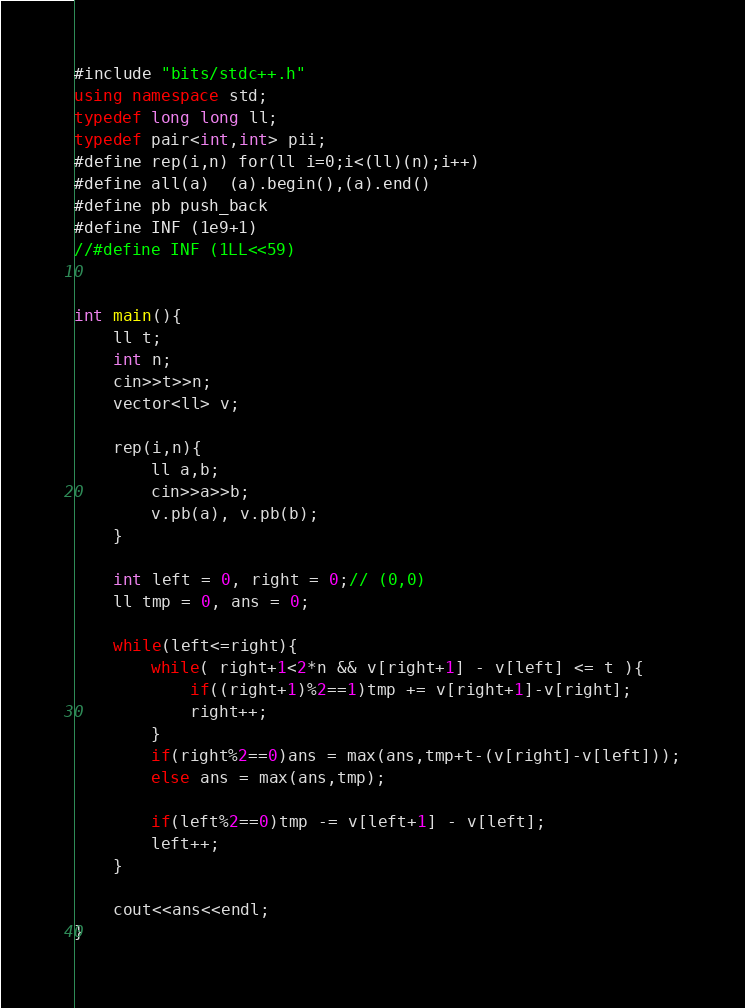Convert code to text. <code><loc_0><loc_0><loc_500><loc_500><_C++_>#include "bits/stdc++.h"
using namespace std;
typedef long long ll;
typedef pair<int,int> pii;
#define rep(i,n) for(ll i=0;i<(ll)(n);i++)
#define all(a)  (a).begin(),(a).end()
#define pb push_back
#define INF (1e9+1)
//#define INF (1LL<<59)


int main(){
	ll t;
	int n;
	cin>>t>>n;
	vector<ll> v;
	
	rep(i,n){
		ll a,b;
		cin>>a>>b;
		v.pb(a), v.pb(b);
	}
	
	int left = 0, right = 0;// (0,0)
	ll tmp = 0, ans = 0;

	while(left<=right){
		while( right+1<2*n && v[right+1] - v[left] <= t ){
			if((right+1)%2==1)tmp += v[right+1]-v[right];
			right++;
		}
		if(right%2==0)ans = max(ans,tmp+t-(v[right]-v[left]));
		else ans = max(ans,tmp);
		
		if(left%2==0)tmp -= v[left+1] - v[left];
		left++;
	}
	
	cout<<ans<<endl;
}</code> 